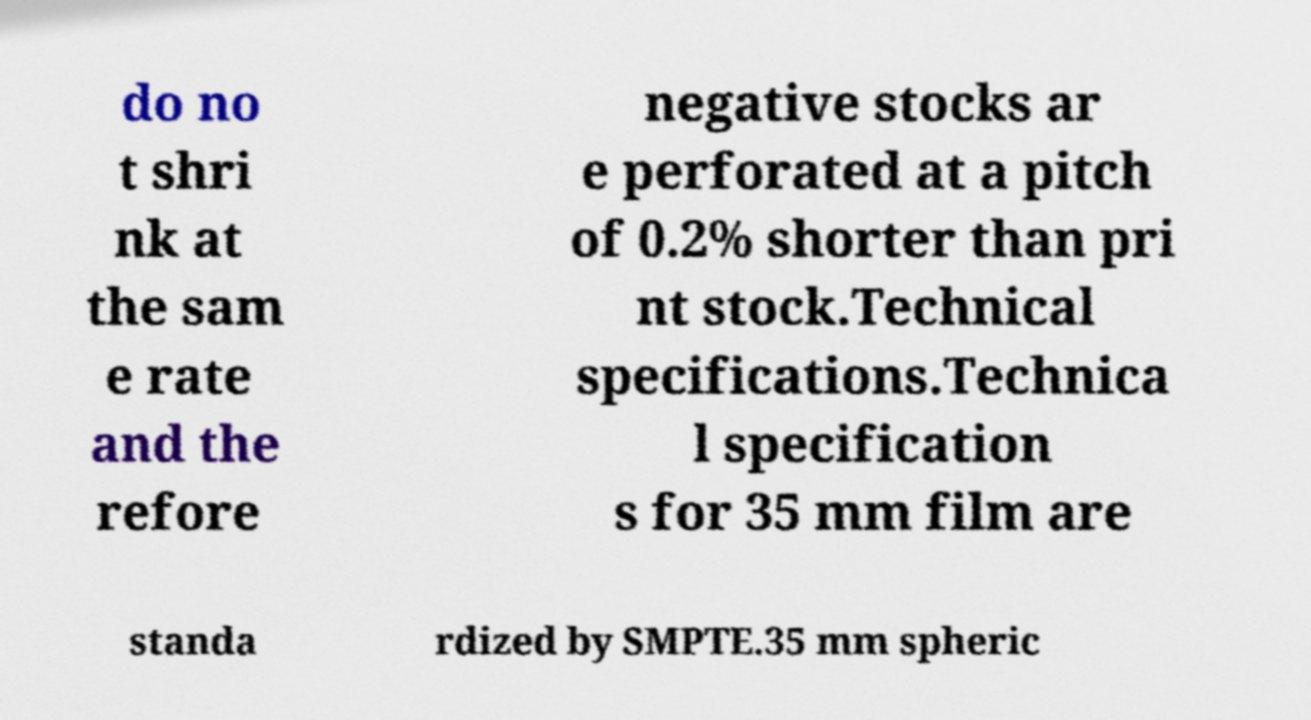Could you assist in decoding the text presented in this image and type it out clearly? do no t shri nk at the sam e rate and the refore negative stocks ar e perforated at a pitch of 0.2% shorter than pri nt stock.Technical specifications.Technica l specification s for 35 mm film are standa rdized by SMPTE.35 mm spheric 